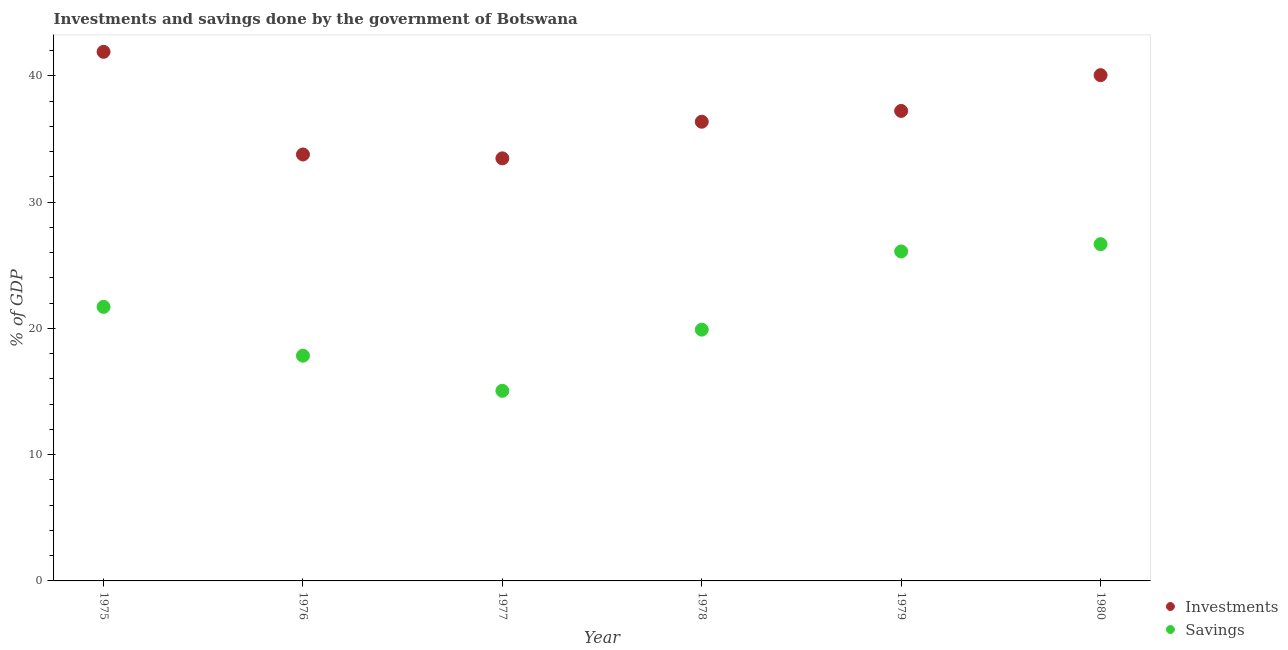Is the number of dotlines equal to the number of legend labels?
Provide a succinct answer. Yes. What is the savings of government in 1978?
Offer a very short reply. 19.9. Across all years, what is the maximum investments of government?
Make the answer very short. 41.9. Across all years, what is the minimum savings of government?
Your answer should be compact. 15.06. What is the total savings of government in the graph?
Offer a very short reply. 127.26. What is the difference between the savings of government in 1979 and that in 1980?
Offer a very short reply. -0.58. What is the difference between the savings of government in 1980 and the investments of government in 1976?
Make the answer very short. -7.1. What is the average savings of government per year?
Ensure brevity in your answer.  21.21. In the year 1978, what is the difference between the savings of government and investments of government?
Provide a short and direct response. -16.46. In how many years, is the savings of government greater than 20 %?
Ensure brevity in your answer.  3. What is the ratio of the savings of government in 1976 to that in 1979?
Ensure brevity in your answer.  0.68. What is the difference between the highest and the second highest investments of government?
Give a very brief answer. 1.85. What is the difference between the highest and the lowest investments of government?
Ensure brevity in your answer.  8.44. Does the savings of government monotonically increase over the years?
Ensure brevity in your answer.  No. Is the investments of government strictly greater than the savings of government over the years?
Provide a short and direct response. Yes. Is the savings of government strictly less than the investments of government over the years?
Ensure brevity in your answer.  Yes. Where does the legend appear in the graph?
Provide a short and direct response. Bottom right. How are the legend labels stacked?
Make the answer very short. Vertical. What is the title of the graph?
Give a very brief answer. Investments and savings done by the government of Botswana. Does "Age 15+" appear as one of the legend labels in the graph?
Offer a terse response. No. What is the label or title of the X-axis?
Ensure brevity in your answer.  Year. What is the label or title of the Y-axis?
Provide a succinct answer. % of GDP. What is the % of GDP in Investments in 1975?
Offer a terse response. 41.9. What is the % of GDP of Savings in 1975?
Ensure brevity in your answer.  21.7. What is the % of GDP in Investments in 1976?
Provide a succinct answer. 33.77. What is the % of GDP in Savings in 1976?
Offer a very short reply. 17.84. What is the % of GDP of Investments in 1977?
Offer a terse response. 33.46. What is the % of GDP in Savings in 1977?
Your response must be concise. 15.06. What is the % of GDP in Investments in 1978?
Your response must be concise. 36.36. What is the % of GDP of Savings in 1978?
Give a very brief answer. 19.9. What is the % of GDP in Investments in 1979?
Offer a very short reply. 37.22. What is the % of GDP of Savings in 1979?
Provide a succinct answer. 26.09. What is the % of GDP in Investments in 1980?
Your answer should be compact. 40.05. What is the % of GDP in Savings in 1980?
Offer a very short reply. 26.67. Across all years, what is the maximum % of GDP of Investments?
Offer a terse response. 41.9. Across all years, what is the maximum % of GDP in Savings?
Keep it short and to the point. 26.67. Across all years, what is the minimum % of GDP in Investments?
Your answer should be very brief. 33.46. Across all years, what is the minimum % of GDP of Savings?
Provide a succinct answer. 15.06. What is the total % of GDP of Investments in the graph?
Ensure brevity in your answer.  222.77. What is the total % of GDP of Savings in the graph?
Keep it short and to the point. 127.26. What is the difference between the % of GDP of Investments in 1975 and that in 1976?
Your answer should be compact. 8.13. What is the difference between the % of GDP of Savings in 1975 and that in 1976?
Give a very brief answer. 3.87. What is the difference between the % of GDP in Investments in 1975 and that in 1977?
Your response must be concise. 8.44. What is the difference between the % of GDP of Savings in 1975 and that in 1977?
Offer a terse response. 6.65. What is the difference between the % of GDP in Investments in 1975 and that in 1978?
Provide a short and direct response. 5.54. What is the difference between the % of GDP in Savings in 1975 and that in 1978?
Ensure brevity in your answer.  1.8. What is the difference between the % of GDP of Investments in 1975 and that in 1979?
Offer a very short reply. 4.68. What is the difference between the % of GDP of Savings in 1975 and that in 1979?
Your answer should be very brief. -4.39. What is the difference between the % of GDP of Investments in 1975 and that in 1980?
Give a very brief answer. 1.85. What is the difference between the % of GDP of Savings in 1975 and that in 1980?
Your answer should be compact. -4.97. What is the difference between the % of GDP in Investments in 1976 and that in 1977?
Your answer should be compact. 0.31. What is the difference between the % of GDP in Savings in 1976 and that in 1977?
Your answer should be compact. 2.78. What is the difference between the % of GDP of Investments in 1976 and that in 1978?
Offer a very short reply. -2.59. What is the difference between the % of GDP of Savings in 1976 and that in 1978?
Provide a succinct answer. -2.06. What is the difference between the % of GDP in Investments in 1976 and that in 1979?
Offer a terse response. -3.45. What is the difference between the % of GDP in Savings in 1976 and that in 1979?
Ensure brevity in your answer.  -8.26. What is the difference between the % of GDP of Investments in 1976 and that in 1980?
Keep it short and to the point. -6.28. What is the difference between the % of GDP of Savings in 1976 and that in 1980?
Your answer should be very brief. -8.83. What is the difference between the % of GDP of Investments in 1977 and that in 1978?
Ensure brevity in your answer.  -2.9. What is the difference between the % of GDP in Savings in 1977 and that in 1978?
Your response must be concise. -4.84. What is the difference between the % of GDP in Investments in 1977 and that in 1979?
Provide a short and direct response. -3.75. What is the difference between the % of GDP of Savings in 1977 and that in 1979?
Ensure brevity in your answer.  -11.04. What is the difference between the % of GDP of Investments in 1977 and that in 1980?
Give a very brief answer. -6.59. What is the difference between the % of GDP in Savings in 1977 and that in 1980?
Give a very brief answer. -11.61. What is the difference between the % of GDP of Investments in 1978 and that in 1979?
Your answer should be compact. -0.86. What is the difference between the % of GDP in Savings in 1978 and that in 1979?
Provide a succinct answer. -6.19. What is the difference between the % of GDP in Investments in 1978 and that in 1980?
Provide a succinct answer. -3.69. What is the difference between the % of GDP of Savings in 1978 and that in 1980?
Your response must be concise. -6.77. What is the difference between the % of GDP of Investments in 1979 and that in 1980?
Keep it short and to the point. -2.83. What is the difference between the % of GDP in Savings in 1979 and that in 1980?
Your answer should be very brief. -0.58. What is the difference between the % of GDP of Investments in 1975 and the % of GDP of Savings in 1976?
Give a very brief answer. 24.06. What is the difference between the % of GDP in Investments in 1975 and the % of GDP in Savings in 1977?
Offer a terse response. 26.84. What is the difference between the % of GDP of Investments in 1975 and the % of GDP of Savings in 1978?
Ensure brevity in your answer.  22. What is the difference between the % of GDP in Investments in 1975 and the % of GDP in Savings in 1979?
Your response must be concise. 15.81. What is the difference between the % of GDP of Investments in 1975 and the % of GDP of Savings in 1980?
Offer a very short reply. 15.23. What is the difference between the % of GDP of Investments in 1976 and the % of GDP of Savings in 1977?
Your response must be concise. 18.72. What is the difference between the % of GDP of Investments in 1976 and the % of GDP of Savings in 1978?
Your answer should be very brief. 13.87. What is the difference between the % of GDP of Investments in 1976 and the % of GDP of Savings in 1979?
Offer a terse response. 7.68. What is the difference between the % of GDP in Investments in 1976 and the % of GDP in Savings in 1980?
Your response must be concise. 7.1. What is the difference between the % of GDP of Investments in 1977 and the % of GDP of Savings in 1978?
Ensure brevity in your answer.  13.56. What is the difference between the % of GDP in Investments in 1977 and the % of GDP in Savings in 1979?
Provide a succinct answer. 7.37. What is the difference between the % of GDP of Investments in 1977 and the % of GDP of Savings in 1980?
Provide a short and direct response. 6.8. What is the difference between the % of GDP of Investments in 1978 and the % of GDP of Savings in 1979?
Provide a short and direct response. 10.27. What is the difference between the % of GDP in Investments in 1978 and the % of GDP in Savings in 1980?
Give a very brief answer. 9.69. What is the difference between the % of GDP in Investments in 1979 and the % of GDP in Savings in 1980?
Your answer should be compact. 10.55. What is the average % of GDP of Investments per year?
Provide a succinct answer. 37.13. What is the average % of GDP of Savings per year?
Offer a terse response. 21.21. In the year 1975, what is the difference between the % of GDP of Investments and % of GDP of Savings?
Keep it short and to the point. 20.2. In the year 1976, what is the difference between the % of GDP of Investments and % of GDP of Savings?
Provide a succinct answer. 15.94. In the year 1977, what is the difference between the % of GDP of Investments and % of GDP of Savings?
Your answer should be compact. 18.41. In the year 1978, what is the difference between the % of GDP of Investments and % of GDP of Savings?
Offer a very short reply. 16.46. In the year 1979, what is the difference between the % of GDP of Investments and % of GDP of Savings?
Your answer should be very brief. 11.13. In the year 1980, what is the difference between the % of GDP of Investments and % of GDP of Savings?
Ensure brevity in your answer.  13.38. What is the ratio of the % of GDP in Investments in 1975 to that in 1976?
Provide a short and direct response. 1.24. What is the ratio of the % of GDP of Savings in 1975 to that in 1976?
Your answer should be compact. 1.22. What is the ratio of the % of GDP in Investments in 1975 to that in 1977?
Keep it short and to the point. 1.25. What is the ratio of the % of GDP of Savings in 1975 to that in 1977?
Offer a very short reply. 1.44. What is the ratio of the % of GDP in Investments in 1975 to that in 1978?
Your answer should be compact. 1.15. What is the ratio of the % of GDP in Savings in 1975 to that in 1978?
Keep it short and to the point. 1.09. What is the ratio of the % of GDP in Investments in 1975 to that in 1979?
Your response must be concise. 1.13. What is the ratio of the % of GDP of Savings in 1975 to that in 1979?
Provide a short and direct response. 0.83. What is the ratio of the % of GDP in Investments in 1975 to that in 1980?
Provide a succinct answer. 1.05. What is the ratio of the % of GDP in Savings in 1975 to that in 1980?
Offer a very short reply. 0.81. What is the ratio of the % of GDP in Investments in 1976 to that in 1977?
Offer a very short reply. 1.01. What is the ratio of the % of GDP in Savings in 1976 to that in 1977?
Give a very brief answer. 1.18. What is the ratio of the % of GDP of Investments in 1976 to that in 1978?
Your response must be concise. 0.93. What is the ratio of the % of GDP in Savings in 1976 to that in 1978?
Provide a short and direct response. 0.9. What is the ratio of the % of GDP of Investments in 1976 to that in 1979?
Provide a succinct answer. 0.91. What is the ratio of the % of GDP in Savings in 1976 to that in 1979?
Provide a short and direct response. 0.68. What is the ratio of the % of GDP of Investments in 1976 to that in 1980?
Ensure brevity in your answer.  0.84. What is the ratio of the % of GDP in Savings in 1976 to that in 1980?
Your answer should be very brief. 0.67. What is the ratio of the % of GDP in Investments in 1977 to that in 1978?
Provide a succinct answer. 0.92. What is the ratio of the % of GDP of Savings in 1977 to that in 1978?
Ensure brevity in your answer.  0.76. What is the ratio of the % of GDP of Investments in 1977 to that in 1979?
Your answer should be very brief. 0.9. What is the ratio of the % of GDP in Savings in 1977 to that in 1979?
Give a very brief answer. 0.58. What is the ratio of the % of GDP in Investments in 1977 to that in 1980?
Give a very brief answer. 0.84. What is the ratio of the % of GDP of Savings in 1977 to that in 1980?
Provide a short and direct response. 0.56. What is the ratio of the % of GDP of Savings in 1978 to that in 1979?
Offer a very short reply. 0.76. What is the ratio of the % of GDP of Investments in 1978 to that in 1980?
Your answer should be very brief. 0.91. What is the ratio of the % of GDP of Savings in 1978 to that in 1980?
Make the answer very short. 0.75. What is the ratio of the % of GDP in Investments in 1979 to that in 1980?
Give a very brief answer. 0.93. What is the ratio of the % of GDP in Savings in 1979 to that in 1980?
Provide a short and direct response. 0.98. What is the difference between the highest and the second highest % of GDP in Investments?
Your answer should be compact. 1.85. What is the difference between the highest and the second highest % of GDP in Savings?
Give a very brief answer. 0.58. What is the difference between the highest and the lowest % of GDP in Investments?
Ensure brevity in your answer.  8.44. What is the difference between the highest and the lowest % of GDP of Savings?
Offer a terse response. 11.61. 